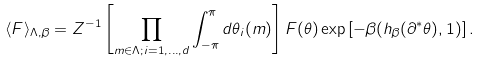<formula> <loc_0><loc_0><loc_500><loc_500>\langle F \rangle _ { \Lambda , \beta } = Z ^ { - 1 } \left [ \prod _ { { m } \in \Lambda ; i = 1 , \dots , d } \int _ { - \pi } ^ { \pi } d \theta _ { i } ( { m } ) \right ] F ( \theta ) \exp \left [ - \beta ( h _ { \beta } ( \partial ^ { \ast } \theta ) , 1 ) \right ] .</formula> 